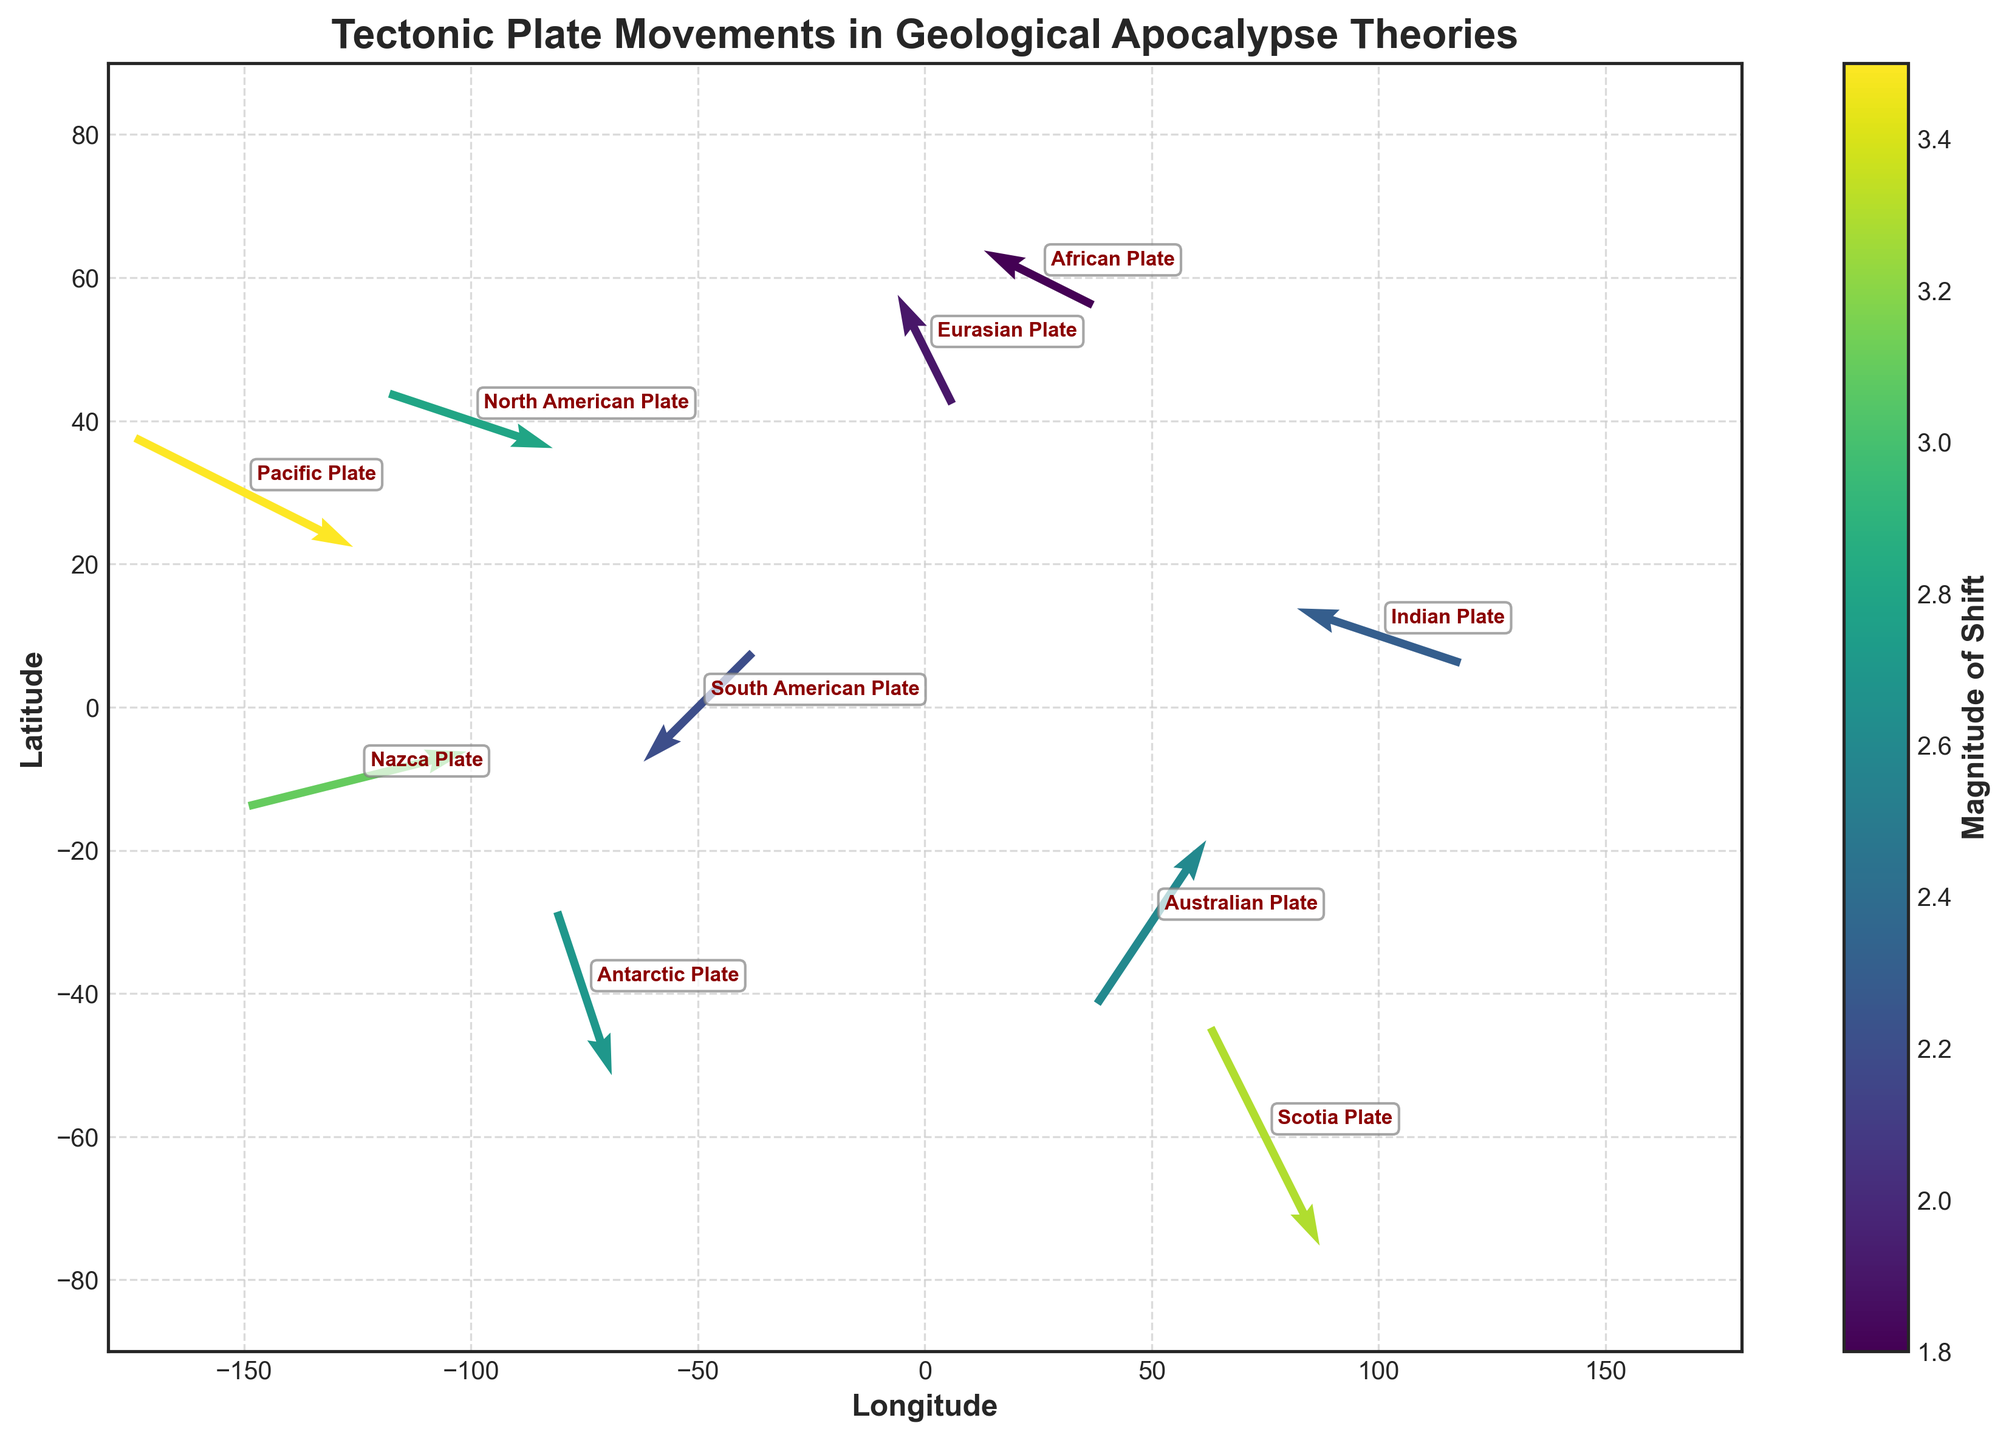How many tectonic plates are shown in the plot? There are 10 data points in the dataset, each representing a different tectonic plate, so there are 10 tectonic plates shown in the plot.
Answer: 10 What is the title of the plot? The title of the plot is displayed at the top center of the figure. It reads "Tectonic Plate Movements in Geological Apocalypse Theories".
Answer: Tectonic Plate Movements in Geological Apocalypse Theories Which tectonic plate has the largest magnitude of shift? By looking at the color intensity and checking the annotations, the Pacific Plate has the highest magnitude of shift which is 3.5.
Answer: Pacific Plate Which direction is the Indian Plate moving? Observing the vector direction associated with the Indian Plate, it is moving westward and slightly northward, indicated by the u and v components (-1.5, 0.5).
Answer: West-Northwest How is the magnitude of the Scotia Plate's shift compared to the Australian Plate's shift? By comparing the color intensities of the vectors, we see that the Scotia Plate has a magnitude of 3.3, while the Australian Plate has 2.6. Therefore, the Scotia Plate's shift magnitude is greater.
Answer: Greater Are there any plates moving predominantly eastward? If so, which ones? By examining the vectors pointing to the right (positive u component), the Nazca Plate and the Pacific Plate are moving predominantly eastward.
Answer: Nazca Plate, Pacific Plate Which directions are indicated by negative values in the u and v vector components for tectonic plates? Plates with negative u values are moving westward, and plates with negative v values are moving southward.
Answer: Westward, Southward Compare the movement of the North American Plate and the Eurasian Plate. Which one is moving more northward? The v value of the North American Plate is -0.5 and for the Eurasian Plate, it is 1. The positive value for the Eurasian Plate indicates it is moving northward, more so than the North American Plate, which moves southward.
Answer: Eurasian Plate What is the sum of the magnitude of shifts for the Nazca Plate and the Scotia Plate? The magnitude for the Nazca Plate is 3.1 and for the Scotia Plate is 3.3. Summing these values gives 3.1 + 3.3 = 6.4.
Answer: 6.4 What's the average longitude position of all the tectonic plates shown? The longitudes are -150, -100, -50, 0, 50, 100, -75, 25, -125, and 75. Summing these values gives -550, and dividing by the number of plates (10) gives -550 / 10 = -55.
Answer: -55 